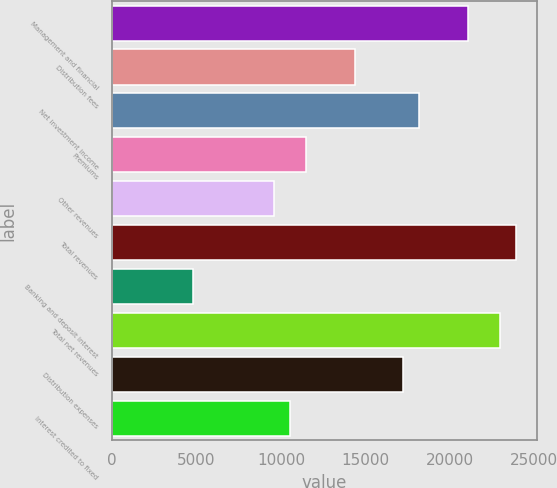Convert chart. <chart><loc_0><loc_0><loc_500><loc_500><bar_chart><fcel>Management and financial<fcel>Distribution fees<fcel>Net investment income<fcel>Premiums<fcel>Other revenues<fcel>Total revenues<fcel>Banking and deposit interest<fcel>Total net revenues<fcel>Distribution expenses<fcel>Interest credited to fixed<nl><fcel>21079.6<fcel>14372.7<fcel>18205.2<fcel>11498.3<fcel>9582.01<fcel>23954<fcel>4791.36<fcel>22995.8<fcel>17247<fcel>10540.1<nl></chart> 